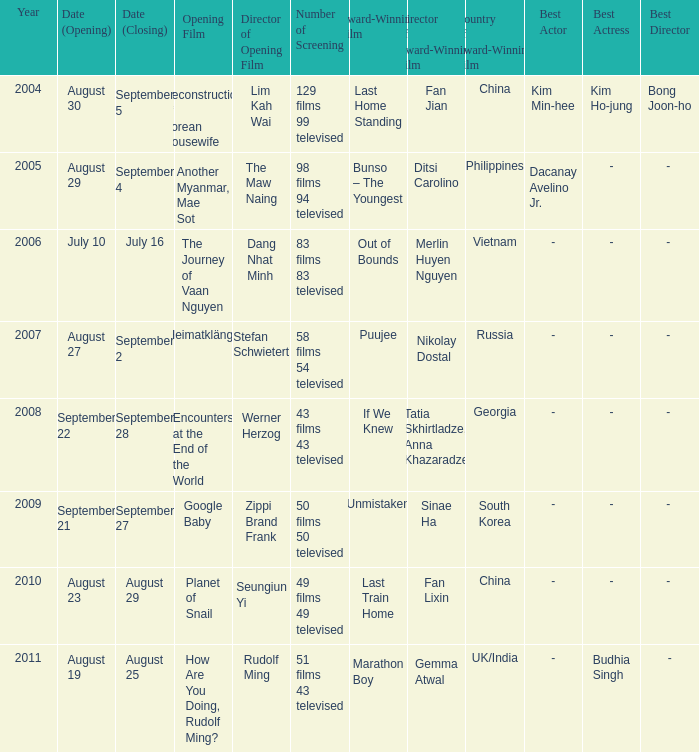What is the number of times the opening film, the journey of vaan nguyen, was screened? 1.0. 